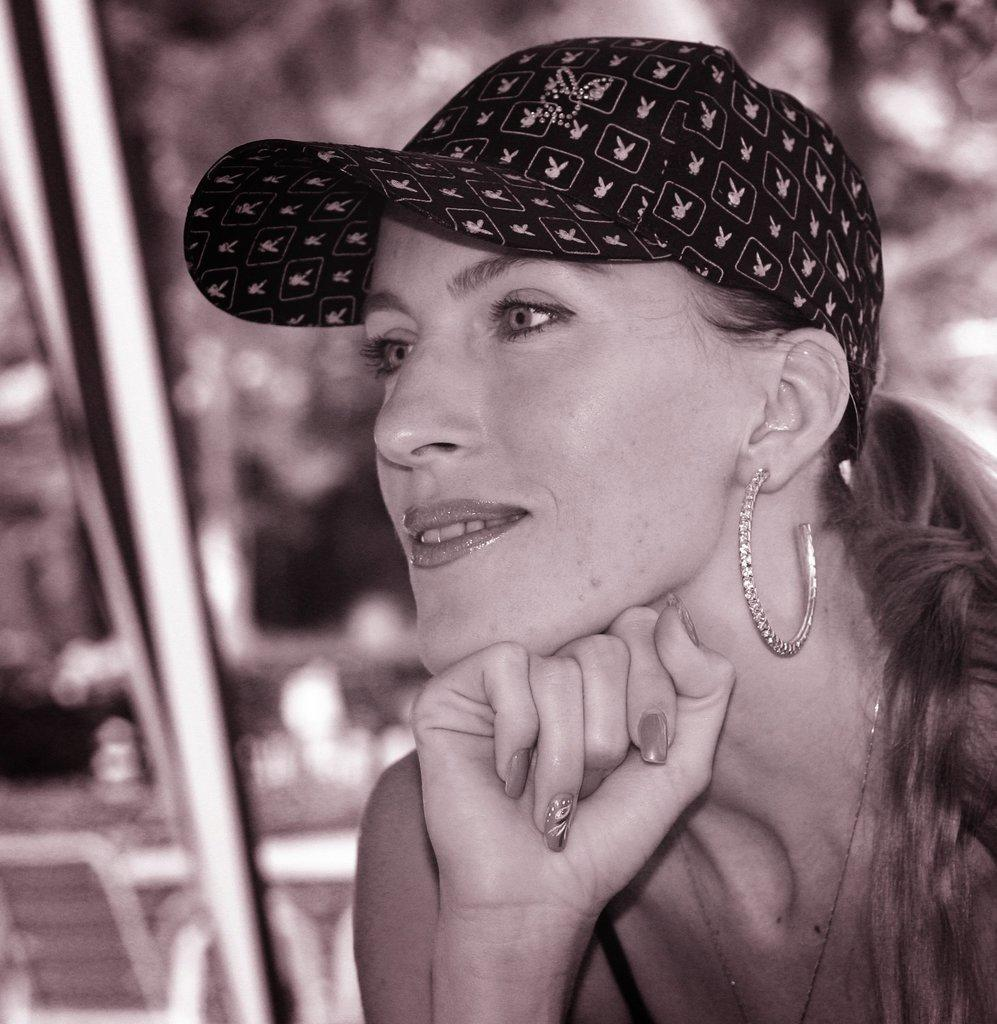Who or what is the main subject of the image? There is a person in the image. Can you describe any accessories the person is wearing? The person is wearing an earring and a cap. How would you describe the background of the image? The background of the image is blurred. What type of brain is visible in the image? There is no brain visible in the image; it features a person wearing an earring and a cap with a blurred background. 